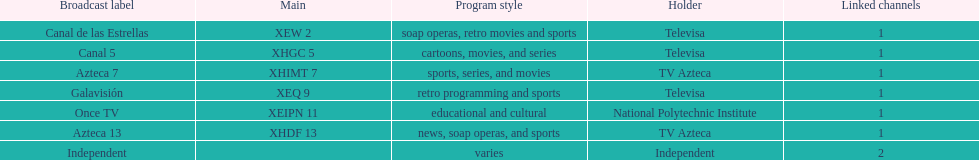How many networks does tv azteca own? 2. 